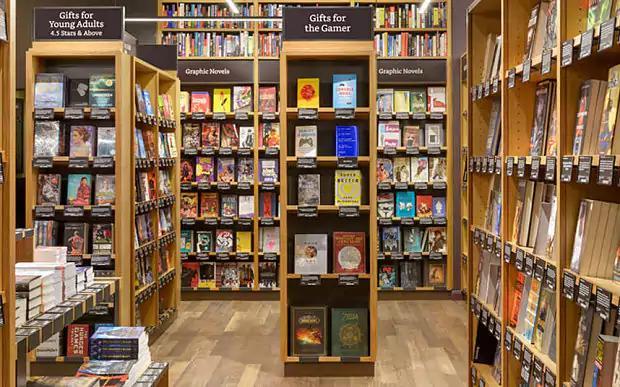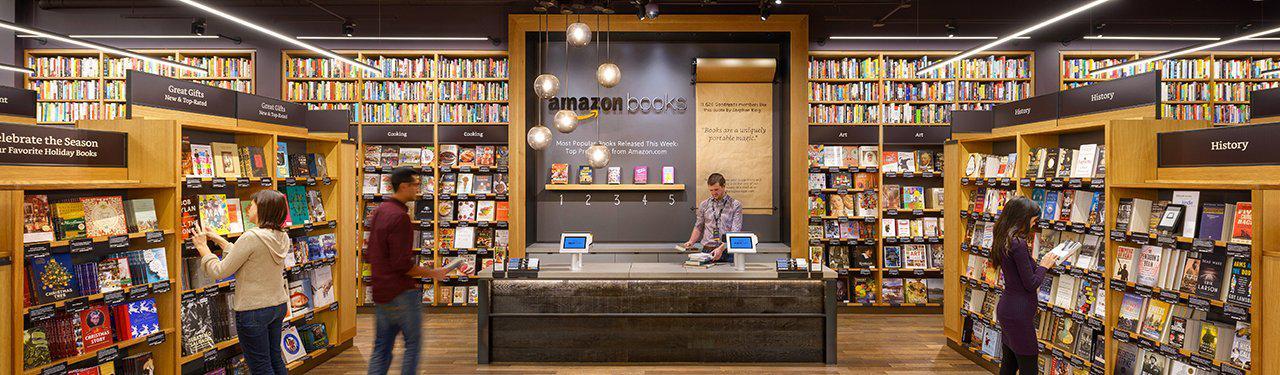The first image is the image on the left, the second image is the image on the right. Analyze the images presented: Is the assertion "One image shows the front entrance of an Amazon books store." valid? Answer yes or no. No. The first image is the image on the left, the second image is the image on the right. For the images displayed, is the sentence "the left image has 2 cash registers" factually correct? Answer yes or no. Yes. 